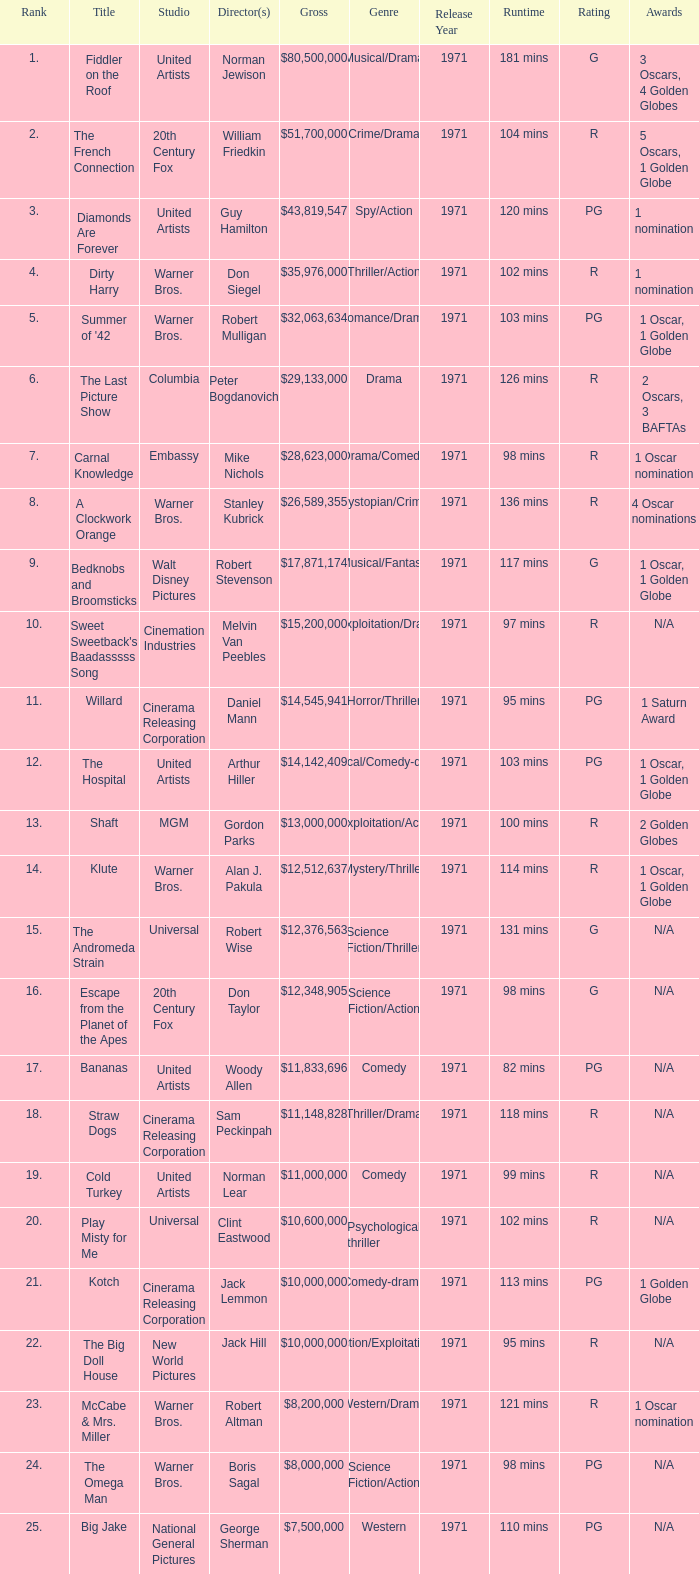What rank is the title with a gross of $26,589,355? 8.0. 